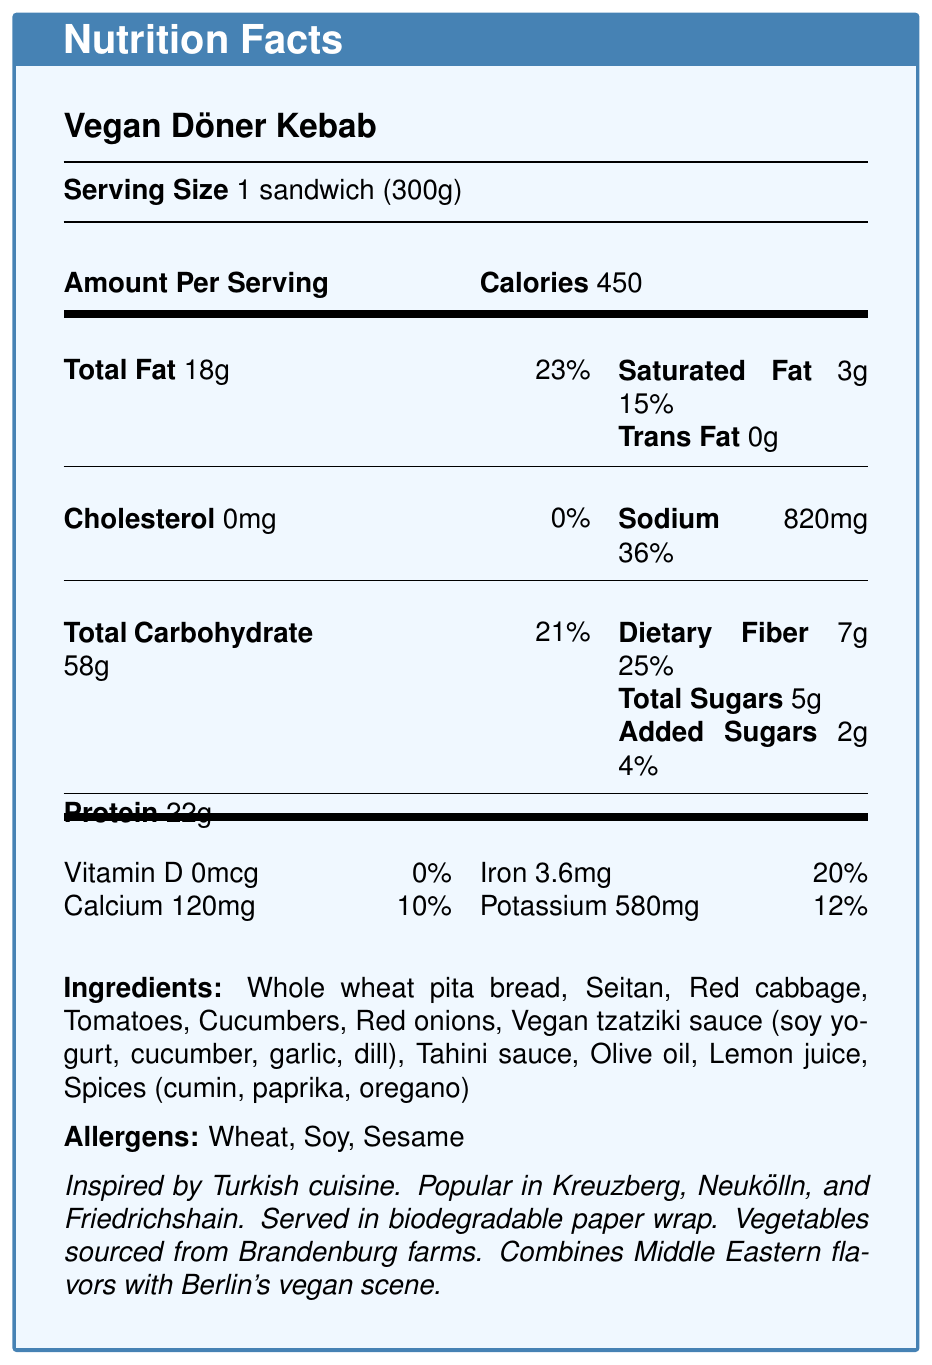what is the serving size of the Vegan Döner Kebab? The serving size is listed in the document as "1 sandwich (300g)".
Answer: 1 sandwich (300g) how many calories are in one serving of the Vegan Döner Kebab? The document specifies that one serving contains 450 calories.
Answer: 450 how much protein does the Vegan Döner Kebab contain per serving? The protein content is indicated as 22g per serving in the document.
Answer: 22g what are the primary allergens listed for the Vegan Döner Kebab? The allergens listed in the document are Wheat, Soy, and Sesame.
Answer: Wheat, Soy, Sesame where are the vegetables used in the Vegan Döner Kebab sourced from? The document states that the vegetables are sourced from Brandenburg farms.
Answer: Brandenburg farms what is the daily value percentage of sodium in the Vegan Döner Kebab? The sodium content is 820mg, which corresponds to 36% of the daily value.
Answer: 36% how much dietary fiber does the Vegan Döner Kebab provide? The dietary fiber content is listed as 7g per serving.
Answer: 7g which of the following vitamins or minerals does the Vegan Döner Kebab contain? A. Vitamin C B. Iron C. Zinc D. Vitamin B12 The document lists Iron content as 3.6mg, but does not mention Vitamin C, Zinc, or Vitamin B12.
Answer: B what type of sauce is included in the Vegan Döner Kebab? A. Hummus B. BBQ Sauce C. Vegan Tzatziki Sauce D. Sriracha The Vegan Döner Kebab includes Vegan Tzatziki Sauce as listed in the ingredients.
Answer: C is there any cholesterol in the Vegan Döner Kebab? The document states that the cholesterol amount is 0mg.
Answer: No describe the additional information provided about the Vegan Döner Kebab. The additional information section of the document describes these details about the Vegan Döner Kebab.
Answer: The Vegan Döner Kebab is inspired by Turkish cuisine, popular in Kreuzberg, Neukölln, and Friedrichshain, served in biodegradable paper wrap, with vegetables sourced from Brandenburg farms, and combines Middle Eastern flavors with Berlin's vegan scene. how long does it take to prepare a Vegan Döner Kebab? The document does not provide information about the preparation time.
Answer: Not enough information how much saturated fat does the Vegan Döner Kebab contain, and what percentage of the daily value does this represent? The saturated fat content is listed as 3g, which represents 15% of the daily value.
Answer: 3g, 15% 